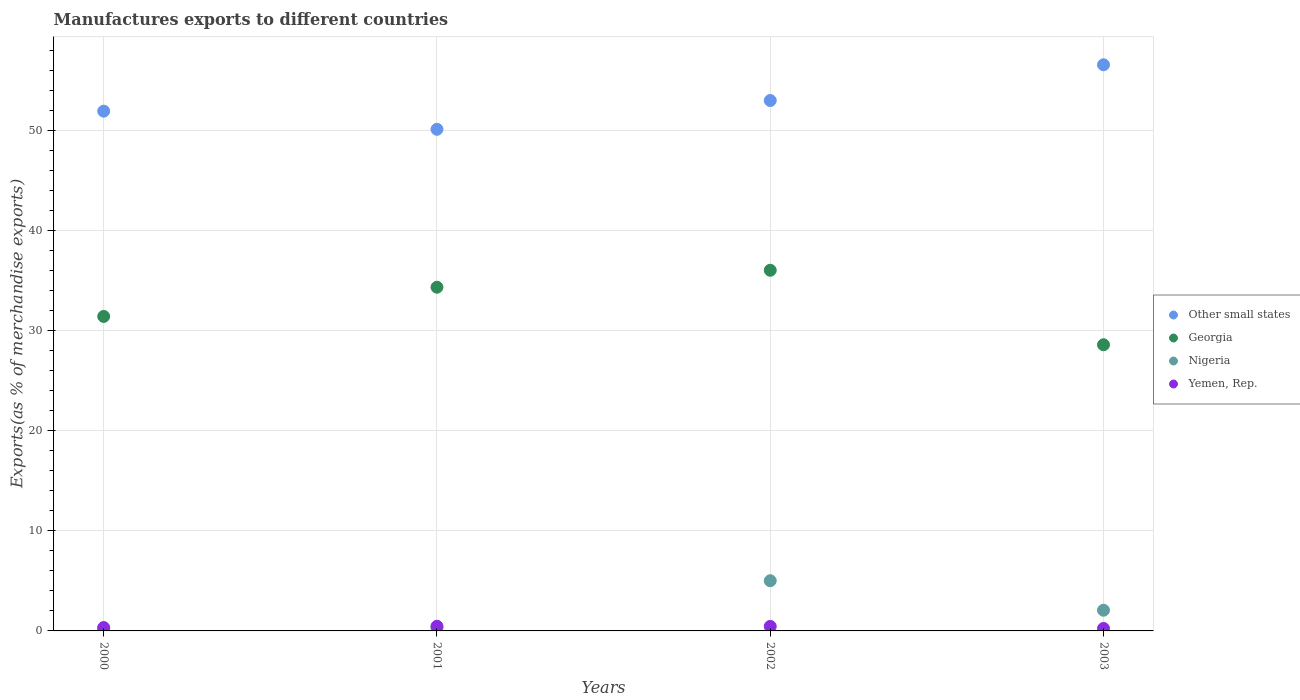How many different coloured dotlines are there?
Provide a short and direct response. 4. Is the number of dotlines equal to the number of legend labels?
Your answer should be very brief. Yes. What is the percentage of exports to different countries in Other small states in 2001?
Your response must be concise. 50.11. Across all years, what is the maximum percentage of exports to different countries in Other small states?
Your answer should be compact. 56.55. Across all years, what is the minimum percentage of exports to different countries in Yemen, Rep.?
Provide a succinct answer. 0.25. In which year was the percentage of exports to different countries in Other small states maximum?
Keep it short and to the point. 2003. In which year was the percentage of exports to different countries in Other small states minimum?
Offer a terse response. 2001. What is the total percentage of exports to different countries in Other small states in the graph?
Your answer should be very brief. 211.56. What is the difference between the percentage of exports to different countries in Georgia in 2001 and that in 2003?
Ensure brevity in your answer.  5.75. What is the difference between the percentage of exports to different countries in Other small states in 2002 and the percentage of exports to different countries in Yemen, Rep. in 2001?
Provide a short and direct response. 52.52. What is the average percentage of exports to different countries in Georgia per year?
Offer a very short reply. 32.59. In the year 2002, what is the difference between the percentage of exports to different countries in Georgia and percentage of exports to different countries in Yemen, Rep.?
Keep it short and to the point. 35.57. In how many years, is the percentage of exports to different countries in Georgia greater than 40 %?
Your answer should be very brief. 0. What is the ratio of the percentage of exports to different countries in Yemen, Rep. in 2001 to that in 2003?
Provide a succinct answer. 1.89. Is the percentage of exports to different countries in Georgia in 2001 less than that in 2002?
Your answer should be very brief. Yes. Is the difference between the percentage of exports to different countries in Georgia in 2000 and 2001 greater than the difference between the percentage of exports to different countries in Yemen, Rep. in 2000 and 2001?
Keep it short and to the point. No. What is the difference between the highest and the second highest percentage of exports to different countries in Georgia?
Provide a succinct answer. 1.69. What is the difference between the highest and the lowest percentage of exports to different countries in Georgia?
Make the answer very short. 7.44. In how many years, is the percentage of exports to different countries in Other small states greater than the average percentage of exports to different countries in Other small states taken over all years?
Provide a short and direct response. 2. Is the sum of the percentage of exports to different countries in Other small states in 2002 and 2003 greater than the maximum percentage of exports to different countries in Yemen, Rep. across all years?
Make the answer very short. Yes. Is it the case that in every year, the sum of the percentage of exports to different countries in Nigeria and percentage of exports to different countries in Yemen, Rep.  is greater than the sum of percentage of exports to different countries in Other small states and percentage of exports to different countries in Georgia?
Provide a succinct answer. No. Does the percentage of exports to different countries in Nigeria monotonically increase over the years?
Keep it short and to the point. No. How many dotlines are there?
Keep it short and to the point. 4. Does the graph contain any zero values?
Give a very brief answer. No. Does the graph contain grids?
Give a very brief answer. Yes. Where does the legend appear in the graph?
Provide a short and direct response. Center right. What is the title of the graph?
Offer a terse response. Manufactures exports to different countries. Does "East Asia (developing only)" appear as one of the legend labels in the graph?
Offer a very short reply. No. What is the label or title of the Y-axis?
Offer a terse response. Exports(as % of merchandise exports). What is the Exports(as % of merchandise exports) of Other small states in 2000?
Your response must be concise. 51.92. What is the Exports(as % of merchandise exports) of Georgia in 2000?
Your answer should be very brief. 31.41. What is the Exports(as % of merchandise exports) in Nigeria in 2000?
Your answer should be compact. 0.21. What is the Exports(as % of merchandise exports) of Yemen, Rep. in 2000?
Ensure brevity in your answer.  0.34. What is the Exports(as % of merchandise exports) of Other small states in 2001?
Provide a succinct answer. 50.11. What is the Exports(as % of merchandise exports) of Georgia in 2001?
Your response must be concise. 34.33. What is the Exports(as % of merchandise exports) in Nigeria in 2001?
Keep it short and to the point. 0.31. What is the Exports(as % of merchandise exports) of Yemen, Rep. in 2001?
Your answer should be compact. 0.47. What is the Exports(as % of merchandise exports) of Other small states in 2002?
Your answer should be very brief. 52.98. What is the Exports(as % of merchandise exports) of Georgia in 2002?
Your answer should be compact. 36.03. What is the Exports(as % of merchandise exports) in Nigeria in 2002?
Offer a terse response. 5.01. What is the Exports(as % of merchandise exports) in Yemen, Rep. in 2002?
Provide a short and direct response. 0.45. What is the Exports(as % of merchandise exports) in Other small states in 2003?
Offer a terse response. 56.55. What is the Exports(as % of merchandise exports) in Georgia in 2003?
Make the answer very short. 28.58. What is the Exports(as % of merchandise exports) of Nigeria in 2003?
Your answer should be compact. 2.07. What is the Exports(as % of merchandise exports) in Yemen, Rep. in 2003?
Your response must be concise. 0.25. Across all years, what is the maximum Exports(as % of merchandise exports) of Other small states?
Offer a very short reply. 56.55. Across all years, what is the maximum Exports(as % of merchandise exports) in Georgia?
Offer a terse response. 36.03. Across all years, what is the maximum Exports(as % of merchandise exports) in Nigeria?
Your response must be concise. 5.01. Across all years, what is the maximum Exports(as % of merchandise exports) in Yemen, Rep.?
Your response must be concise. 0.47. Across all years, what is the minimum Exports(as % of merchandise exports) of Other small states?
Offer a very short reply. 50.11. Across all years, what is the minimum Exports(as % of merchandise exports) of Georgia?
Offer a terse response. 28.58. Across all years, what is the minimum Exports(as % of merchandise exports) of Nigeria?
Your answer should be very brief. 0.21. Across all years, what is the minimum Exports(as % of merchandise exports) of Yemen, Rep.?
Provide a succinct answer. 0.25. What is the total Exports(as % of merchandise exports) of Other small states in the graph?
Ensure brevity in your answer.  211.56. What is the total Exports(as % of merchandise exports) in Georgia in the graph?
Ensure brevity in your answer.  130.36. What is the total Exports(as % of merchandise exports) in Nigeria in the graph?
Keep it short and to the point. 7.6. What is the total Exports(as % of merchandise exports) of Yemen, Rep. in the graph?
Ensure brevity in your answer.  1.5. What is the difference between the Exports(as % of merchandise exports) in Other small states in 2000 and that in 2001?
Make the answer very short. 1.81. What is the difference between the Exports(as % of merchandise exports) of Georgia in 2000 and that in 2001?
Keep it short and to the point. -2.92. What is the difference between the Exports(as % of merchandise exports) in Nigeria in 2000 and that in 2001?
Your response must be concise. -0.1. What is the difference between the Exports(as % of merchandise exports) of Yemen, Rep. in 2000 and that in 2001?
Make the answer very short. -0.13. What is the difference between the Exports(as % of merchandise exports) of Other small states in 2000 and that in 2002?
Give a very brief answer. -1.06. What is the difference between the Exports(as % of merchandise exports) in Georgia in 2000 and that in 2002?
Your response must be concise. -4.61. What is the difference between the Exports(as % of merchandise exports) in Nigeria in 2000 and that in 2002?
Provide a succinct answer. -4.81. What is the difference between the Exports(as % of merchandise exports) of Yemen, Rep. in 2000 and that in 2002?
Offer a terse response. -0.11. What is the difference between the Exports(as % of merchandise exports) in Other small states in 2000 and that in 2003?
Give a very brief answer. -4.63. What is the difference between the Exports(as % of merchandise exports) in Georgia in 2000 and that in 2003?
Provide a succinct answer. 2.83. What is the difference between the Exports(as % of merchandise exports) in Nigeria in 2000 and that in 2003?
Ensure brevity in your answer.  -1.86. What is the difference between the Exports(as % of merchandise exports) of Yemen, Rep. in 2000 and that in 2003?
Provide a short and direct response. 0.09. What is the difference between the Exports(as % of merchandise exports) in Other small states in 2001 and that in 2002?
Provide a short and direct response. -2.87. What is the difference between the Exports(as % of merchandise exports) in Georgia in 2001 and that in 2002?
Ensure brevity in your answer.  -1.69. What is the difference between the Exports(as % of merchandise exports) in Nigeria in 2001 and that in 2002?
Give a very brief answer. -4.71. What is the difference between the Exports(as % of merchandise exports) in Yemen, Rep. in 2001 and that in 2002?
Your answer should be very brief. 0.02. What is the difference between the Exports(as % of merchandise exports) of Other small states in 2001 and that in 2003?
Offer a very short reply. -6.44. What is the difference between the Exports(as % of merchandise exports) of Georgia in 2001 and that in 2003?
Offer a very short reply. 5.75. What is the difference between the Exports(as % of merchandise exports) in Nigeria in 2001 and that in 2003?
Ensure brevity in your answer.  -1.76. What is the difference between the Exports(as % of merchandise exports) of Yemen, Rep. in 2001 and that in 2003?
Offer a terse response. 0.22. What is the difference between the Exports(as % of merchandise exports) in Other small states in 2002 and that in 2003?
Keep it short and to the point. -3.57. What is the difference between the Exports(as % of merchandise exports) in Georgia in 2002 and that in 2003?
Ensure brevity in your answer.  7.44. What is the difference between the Exports(as % of merchandise exports) in Nigeria in 2002 and that in 2003?
Offer a terse response. 2.95. What is the difference between the Exports(as % of merchandise exports) of Yemen, Rep. in 2002 and that in 2003?
Make the answer very short. 0.2. What is the difference between the Exports(as % of merchandise exports) of Other small states in 2000 and the Exports(as % of merchandise exports) of Georgia in 2001?
Offer a terse response. 17.59. What is the difference between the Exports(as % of merchandise exports) of Other small states in 2000 and the Exports(as % of merchandise exports) of Nigeria in 2001?
Provide a short and direct response. 51.61. What is the difference between the Exports(as % of merchandise exports) in Other small states in 2000 and the Exports(as % of merchandise exports) in Yemen, Rep. in 2001?
Offer a very short reply. 51.45. What is the difference between the Exports(as % of merchandise exports) in Georgia in 2000 and the Exports(as % of merchandise exports) in Nigeria in 2001?
Your answer should be very brief. 31.11. What is the difference between the Exports(as % of merchandise exports) of Georgia in 2000 and the Exports(as % of merchandise exports) of Yemen, Rep. in 2001?
Make the answer very short. 30.95. What is the difference between the Exports(as % of merchandise exports) of Nigeria in 2000 and the Exports(as % of merchandise exports) of Yemen, Rep. in 2001?
Provide a short and direct response. -0.26. What is the difference between the Exports(as % of merchandise exports) in Other small states in 2000 and the Exports(as % of merchandise exports) in Georgia in 2002?
Offer a terse response. 15.89. What is the difference between the Exports(as % of merchandise exports) in Other small states in 2000 and the Exports(as % of merchandise exports) in Nigeria in 2002?
Your answer should be very brief. 46.9. What is the difference between the Exports(as % of merchandise exports) of Other small states in 2000 and the Exports(as % of merchandise exports) of Yemen, Rep. in 2002?
Offer a very short reply. 51.47. What is the difference between the Exports(as % of merchandise exports) of Georgia in 2000 and the Exports(as % of merchandise exports) of Nigeria in 2002?
Your answer should be very brief. 26.4. What is the difference between the Exports(as % of merchandise exports) in Georgia in 2000 and the Exports(as % of merchandise exports) in Yemen, Rep. in 2002?
Offer a very short reply. 30.96. What is the difference between the Exports(as % of merchandise exports) of Nigeria in 2000 and the Exports(as % of merchandise exports) of Yemen, Rep. in 2002?
Provide a succinct answer. -0.24. What is the difference between the Exports(as % of merchandise exports) in Other small states in 2000 and the Exports(as % of merchandise exports) in Georgia in 2003?
Your response must be concise. 23.33. What is the difference between the Exports(as % of merchandise exports) in Other small states in 2000 and the Exports(as % of merchandise exports) in Nigeria in 2003?
Make the answer very short. 49.85. What is the difference between the Exports(as % of merchandise exports) in Other small states in 2000 and the Exports(as % of merchandise exports) in Yemen, Rep. in 2003?
Offer a very short reply. 51.67. What is the difference between the Exports(as % of merchandise exports) in Georgia in 2000 and the Exports(as % of merchandise exports) in Nigeria in 2003?
Make the answer very short. 29.35. What is the difference between the Exports(as % of merchandise exports) in Georgia in 2000 and the Exports(as % of merchandise exports) in Yemen, Rep. in 2003?
Your answer should be very brief. 31.17. What is the difference between the Exports(as % of merchandise exports) in Nigeria in 2000 and the Exports(as % of merchandise exports) in Yemen, Rep. in 2003?
Offer a very short reply. -0.04. What is the difference between the Exports(as % of merchandise exports) of Other small states in 2001 and the Exports(as % of merchandise exports) of Georgia in 2002?
Keep it short and to the point. 14.08. What is the difference between the Exports(as % of merchandise exports) in Other small states in 2001 and the Exports(as % of merchandise exports) in Nigeria in 2002?
Ensure brevity in your answer.  45.09. What is the difference between the Exports(as % of merchandise exports) in Other small states in 2001 and the Exports(as % of merchandise exports) in Yemen, Rep. in 2002?
Your response must be concise. 49.66. What is the difference between the Exports(as % of merchandise exports) in Georgia in 2001 and the Exports(as % of merchandise exports) in Nigeria in 2002?
Give a very brief answer. 29.32. What is the difference between the Exports(as % of merchandise exports) in Georgia in 2001 and the Exports(as % of merchandise exports) in Yemen, Rep. in 2002?
Ensure brevity in your answer.  33.88. What is the difference between the Exports(as % of merchandise exports) of Nigeria in 2001 and the Exports(as % of merchandise exports) of Yemen, Rep. in 2002?
Provide a succinct answer. -0.14. What is the difference between the Exports(as % of merchandise exports) of Other small states in 2001 and the Exports(as % of merchandise exports) of Georgia in 2003?
Your answer should be compact. 21.52. What is the difference between the Exports(as % of merchandise exports) of Other small states in 2001 and the Exports(as % of merchandise exports) of Nigeria in 2003?
Offer a very short reply. 48.04. What is the difference between the Exports(as % of merchandise exports) in Other small states in 2001 and the Exports(as % of merchandise exports) in Yemen, Rep. in 2003?
Provide a succinct answer. 49.86. What is the difference between the Exports(as % of merchandise exports) of Georgia in 2001 and the Exports(as % of merchandise exports) of Nigeria in 2003?
Your response must be concise. 32.26. What is the difference between the Exports(as % of merchandise exports) of Georgia in 2001 and the Exports(as % of merchandise exports) of Yemen, Rep. in 2003?
Keep it short and to the point. 34.09. What is the difference between the Exports(as % of merchandise exports) of Nigeria in 2001 and the Exports(as % of merchandise exports) of Yemen, Rep. in 2003?
Make the answer very short. 0.06. What is the difference between the Exports(as % of merchandise exports) in Other small states in 2002 and the Exports(as % of merchandise exports) in Georgia in 2003?
Ensure brevity in your answer.  24.4. What is the difference between the Exports(as % of merchandise exports) of Other small states in 2002 and the Exports(as % of merchandise exports) of Nigeria in 2003?
Keep it short and to the point. 50.91. What is the difference between the Exports(as % of merchandise exports) in Other small states in 2002 and the Exports(as % of merchandise exports) in Yemen, Rep. in 2003?
Make the answer very short. 52.74. What is the difference between the Exports(as % of merchandise exports) of Georgia in 2002 and the Exports(as % of merchandise exports) of Nigeria in 2003?
Ensure brevity in your answer.  33.96. What is the difference between the Exports(as % of merchandise exports) of Georgia in 2002 and the Exports(as % of merchandise exports) of Yemen, Rep. in 2003?
Offer a terse response. 35.78. What is the difference between the Exports(as % of merchandise exports) of Nigeria in 2002 and the Exports(as % of merchandise exports) of Yemen, Rep. in 2003?
Provide a short and direct response. 4.77. What is the average Exports(as % of merchandise exports) of Other small states per year?
Offer a terse response. 52.89. What is the average Exports(as % of merchandise exports) of Georgia per year?
Your answer should be very brief. 32.59. What is the average Exports(as % of merchandise exports) in Nigeria per year?
Your answer should be very brief. 1.9. What is the average Exports(as % of merchandise exports) in Yemen, Rep. per year?
Provide a short and direct response. 0.38. In the year 2000, what is the difference between the Exports(as % of merchandise exports) in Other small states and Exports(as % of merchandise exports) in Georgia?
Provide a short and direct response. 20.5. In the year 2000, what is the difference between the Exports(as % of merchandise exports) of Other small states and Exports(as % of merchandise exports) of Nigeria?
Your answer should be very brief. 51.71. In the year 2000, what is the difference between the Exports(as % of merchandise exports) in Other small states and Exports(as % of merchandise exports) in Yemen, Rep.?
Provide a succinct answer. 51.58. In the year 2000, what is the difference between the Exports(as % of merchandise exports) in Georgia and Exports(as % of merchandise exports) in Nigeria?
Offer a very short reply. 31.21. In the year 2000, what is the difference between the Exports(as % of merchandise exports) of Georgia and Exports(as % of merchandise exports) of Yemen, Rep.?
Keep it short and to the point. 31.08. In the year 2000, what is the difference between the Exports(as % of merchandise exports) in Nigeria and Exports(as % of merchandise exports) in Yemen, Rep.?
Provide a short and direct response. -0.13. In the year 2001, what is the difference between the Exports(as % of merchandise exports) in Other small states and Exports(as % of merchandise exports) in Georgia?
Provide a short and direct response. 15.78. In the year 2001, what is the difference between the Exports(as % of merchandise exports) of Other small states and Exports(as % of merchandise exports) of Nigeria?
Keep it short and to the point. 49.8. In the year 2001, what is the difference between the Exports(as % of merchandise exports) in Other small states and Exports(as % of merchandise exports) in Yemen, Rep.?
Make the answer very short. 49.64. In the year 2001, what is the difference between the Exports(as % of merchandise exports) of Georgia and Exports(as % of merchandise exports) of Nigeria?
Keep it short and to the point. 34.02. In the year 2001, what is the difference between the Exports(as % of merchandise exports) in Georgia and Exports(as % of merchandise exports) in Yemen, Rep.?
Offer a very short reply. 33.87. In the year 2001, what is the difference between the Exports(as % of merchandise exports) of Nigeria and Exports(as % of merchandise exports) of Yemen, Rep.?
Give a very brief answer. -0.16. In the year 2002, what is the difference between the Exports(as % of merchandise exports) in Other small states and Exports(as % of merchandise exports) in Georgia?
Offer a very short reply. 16.96. In the year 2002, what is the difference between the Exports(as % of merchandise exports) in Other small states and Exports(as % of merchandise exports) in Nigeria?
Your response must be concise. 47.97. In the year 2002, what is the difference between the Exports(as % of merchandise exports) of Other small states and Exports(as % of merchandise exports) of Yemen, Rep.?
Provide a short and direct response. 52.53. In the year 2002, what is the difference between the Exports(as % of merchandise exports) of Georgia and Exports(as % of merchandise exports) of Nigeria?
Offer a very short reply. 31.01. In the year 2002, what is the difference between the Exports(as % of merchandise exports) in Georgia and Exports(as % of merchandise exports) in Yemen, Rep.?
Ensure brevity in your answer.  35.57. In the year 2002, what is the difference between the Exports(as % of merchandise exports) of Nigeria and Exports(as % of merchandise exports) of Yemen, Rep.?
Make the answer very short. 4.56. In the year 2003, what is the difference between the Exports(as % of merchandise exports) of Other small states and Exports(as % of merchandise exports) of Georgia?
Provide a short and direct response. 27.97. In the year 2003, what is the difference between the Exports(as % of merchandise exports) of Other small states and Exports(as % of merchandise exports) of Nigeria?
Ensure brevity in your answer.  54.48. In the year 2003, what is the difference between the Exports(as % of merchandise exports) in Other small states and Exports(as % of merchandise exports) in Yemen, Rep.?
Your answer should be compact. 56.3. In the year 2003, what is the difference between the Exports(as % of merchandise exports) of Georgia and Exports(as % of merchandise exports) of Nigeria?
Ensure brevity in your answer.  26.52. In the year 2003, what is the difference between the Exports(as % of merchandise exports) of Georgia and Exports(as % of merchandise exports) of Yemen, Rep.?
Ensure brevity in your answer.  28.34. In the year 2003, what is the difference between the Exports(as % of merchandise exports) of Nigeria and Exports(as % of merchandise exports) of Yemen, Rep.?
Your response must be concise. 1.82. What is the ratio of the Exports(as % of merchandise exports) in Other small states in 2000 to that in 2001?
Provide a succinct answer. 1.04. What is the ratio of the Exports(as % of merchandise exports) of Georgia in 2000 to that in 2001?
Give a very brief answer. 0.92. What is the ratio of the Exports(as % of merchandise exports) of Nigeria in 2000 to that in 2001?
Keep it short and to the point. 0.67. What is the ratio of the Exports(as % of merchandise exports) in Yemen, Rep. in 2000 to that in 2001?
Ensure brevity in your answer.  0.72. What is the ratio of the Exports(as % of merchandise exports) of Other small states in 2000 to that in 2002?
Ensure brevity in your answer.  0.98. What is the ratio of the Exports(as % of merchandise exports) of Georgia in 2000 to that in 2002?
Your answer should be compact. 0.87. What is the ratio of the Exports(as % of merchandise exports) of Nigeria in 2000 to that in 2002?
Keep it short and to the point. 0.04. What is the ratio of the Exports(as % of merchandise exports) of Yemen, Rep. in 2000 to that in 2002?
Keep it short and to the point. 0.75. What is the ratio of the Exports(as % of merchandise exports) of Other small states in 2000 to that in 2003?
Your response must be concise. 0.92. What is the ratio of the Exports(as % of merchandise exports) in Georgia in 2000 to that in 2003?
Keep it short and to the point. 1.1. What is the ratio of the Exports(as % of merchandise exports) of Nigeria in 2000 to that in 2003?
Provide a succinct answer. 0.1. What is the ratio of the Exports(as % of merchandise exports) in Yemen, Rep. in 2000 to that in 2003?
Give a very brief answer. 1.37. What is the ratio of the Exports(as % of merchandise exports) in Other small states in 2001 to that in 2002?
Your response must be concise. 0.95. What is the ratio of the Exports(as % of merchandise exports) in Georgia in 2001 to that in 2002?
Your response must be concise. 0.95. What is the ratio of the Exports(as % of merchandise exports) of Nigeria in 2001 to that in 2002?
Your response must be concise. 0.06. What is the ratio of the Exports(as % of merchandise exports) in Yemen, Rep. in 2001 to that in 2002?
Your answer should be compact. 1.03. What is the ratio of the Exports(as % of merchandise exports) of Other small states in 2001 to that in 2003?
Keep it short and to the point. 0.89. What is the ratio of the Exports(as % of merchandise exports) in Georgia in 2001 to that in 2003?
Your response must be concise. 1.2. What is the ratio of the Exports(as % of merchandise exports) of Nigeria in 2001 to that in 2003?
Ensure brevity in your answer.  0.15. What is the ratio of the Exports(as % of merchandise exports) in Yemen, Rep. in 2001 to that in 2003?
Provide a short and direct response. 1.89. What is the ratio of the Exports(as % of merchandise exports) in Other small states in 2002 to that in 2003?
Offer a terse response. 0.94. What is the ratio of the Exports(as % of merchandise exports) in Georgia in 2002 to that in 2003?
Your answer should be compact. 1.26. What is the ratio of the Exports(as % of merchandise exports) in Nigeria in 2002 to that in 2003?
Offer a terse response. 2.43. What is the ratio of the Exports(as % of merchandise exports) of Yemen, Rep. in 2002 to that in 2003?
Provide a short and direct response. 1.83. What is the difference between the highest and the second highest Exports(as % of merchandise exports) of Other small states?
Offer a very short reply. 3.57. What is the difference between the highest and the second highest Exports(as % of merchandise exports) of Georgia?
Offer a terse response. 1.69. What is the difference between the highest and the second highest Exports(as % of merchandise exports) in Nigeria?
Ensure brevity in your answer.  2.95. What is the difference between the highest and the second highest Exports(as % of merchandise exports) of Yemen, Rep.?
Your answer should be compact. 0.02. What is the difference between the highest and the lowest Exports(as % of merchandise exports) of Other small states?
Offer a terse response. 6.44. What is the difference between the highest and the lowest Exports(as % of merchandise exports) of Georgia?
Provide a succinct answer. 7.44. What is the difference between the highest and the lowest Exports(as % of merchandise exports) in Nigeria?
Provide a succinct answer. 4.81. What is the difference between the highest and the lowest Exports(as % of merchandise exports) of Yemen, Rep.?
Your response must be concise. 0.22. 